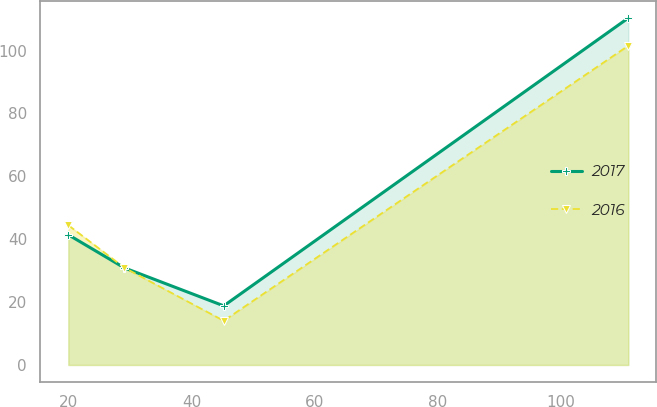Convert chart. <chart><loc_0><loc_0><loc_500><loc_500><line_chart><ecel><fcel>2017<fcel>2016<nl><fcel>19.99<fcel>41.42<fcel>44.45<nl><fcel>29.1<fcel>30.88<fcel>30.93<nl><fcel>45.26<fcel>18.8<fcel>14.05<nl><fcel>111.05<fcel>110.37<fcel>101.56<nl></chart> 